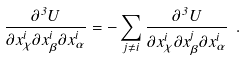<formula> <loc_0><loc_0><loc_500><loc_500>\frac { \partial ^ { 3 } U } { \partial x ^ { i } _ { \chi } \partial x ^ { i } _ { \beta } \partial x ^ { i } _ { \alpha } } = - \sum _ { j \ne i } \frac { \partial ^ { 3 } U } { \partial x ^ { i } _ { \chi } \partial x ^ { j } _ { \beta } \partial x ^ { i } _ { \alpha } } \ .</formula> 